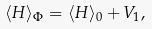Convert formula to latex. <formula><loc_0><loc_0><loc_500><loc_500>\langle H \rangle _ { \Phi } = \langle H \rangle _ { 0 } + V _ { 1 } ,</formula> 